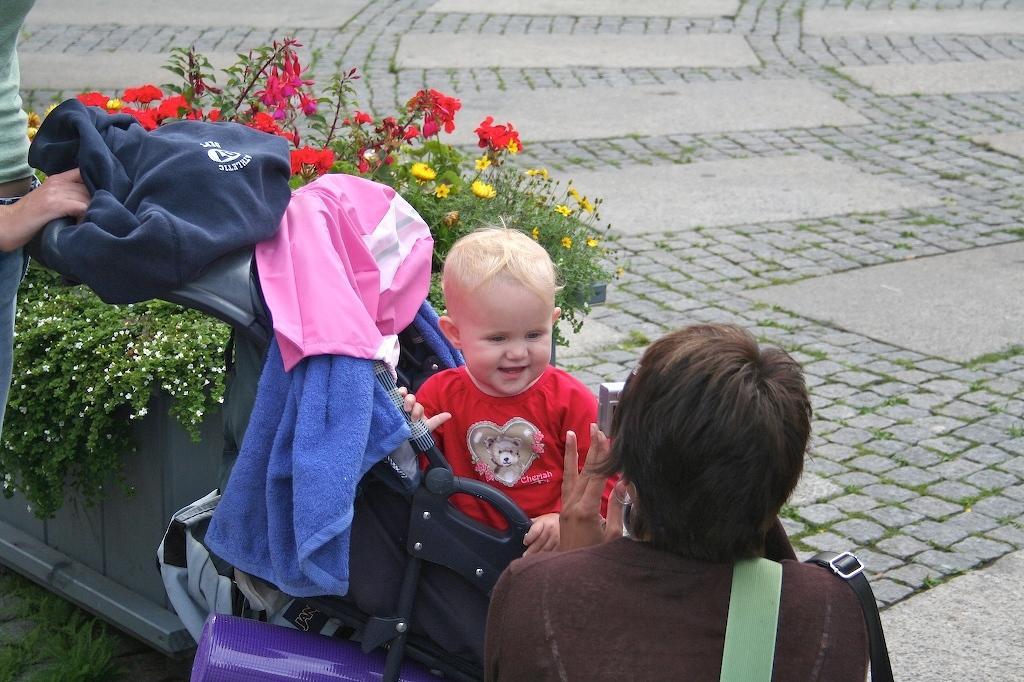Please provide a concise description of this image. On the bottom there is a woman who is holding a camera and taking picture of a boy who is wearing t-shirt. He is sitting on the trolley. On the left there is another woman who is holding this trolley. Beside her we can see flowers and plants on the pot. On the right we can see the floor. 